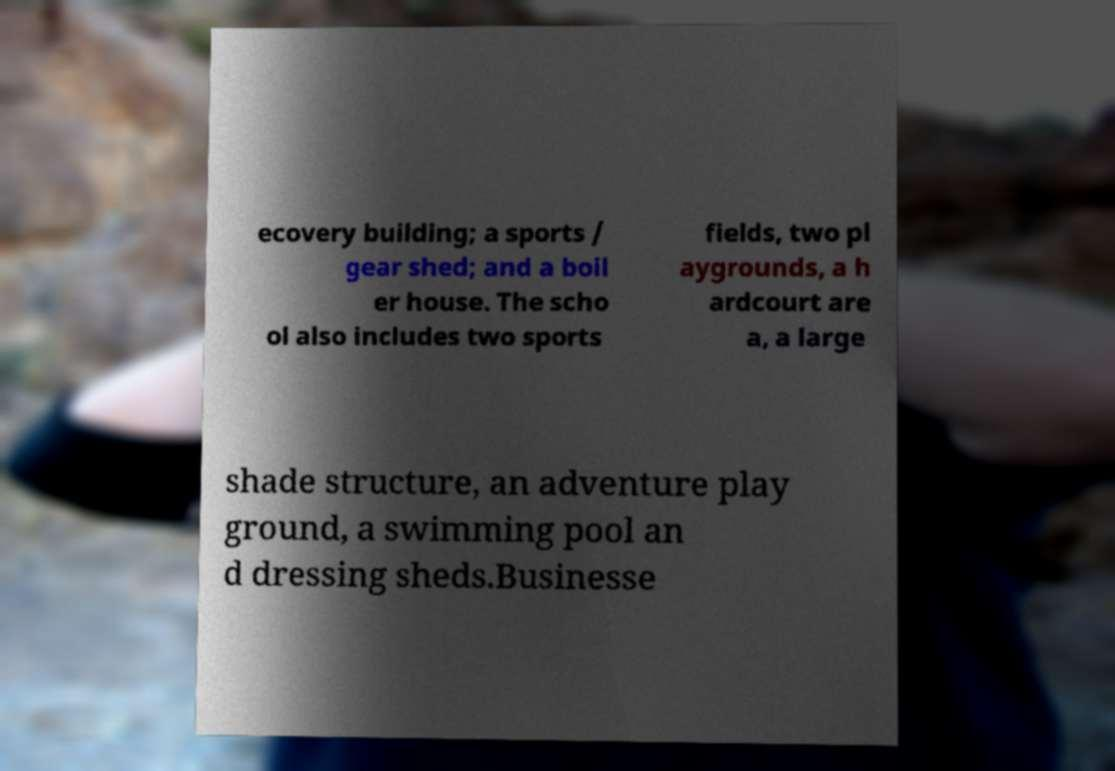Could you extract and type out the text from this image? ecovery building; a sports / gear shed; and a boil er house. The scho ol also includes two sports fields, two pl aygrounds, a h ardcourt are a, a large shade structure, an adventure play ground, a swimming pool an d dressing sheds.Businesse 